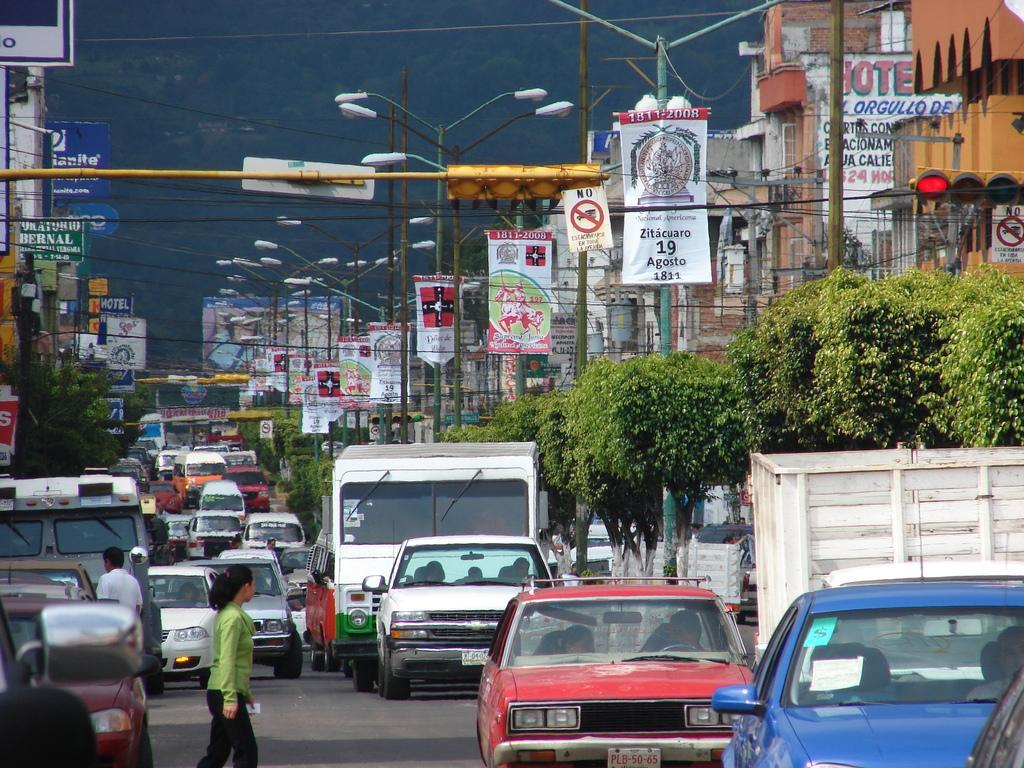Could you give a brief overview of what you see in this image? Here on the road we can see few vehicles and two persons on the road. In the background there are trees,street lights,hoardings,traffic signal pole,buildings,banners,sign boards,electric wires and sky. 